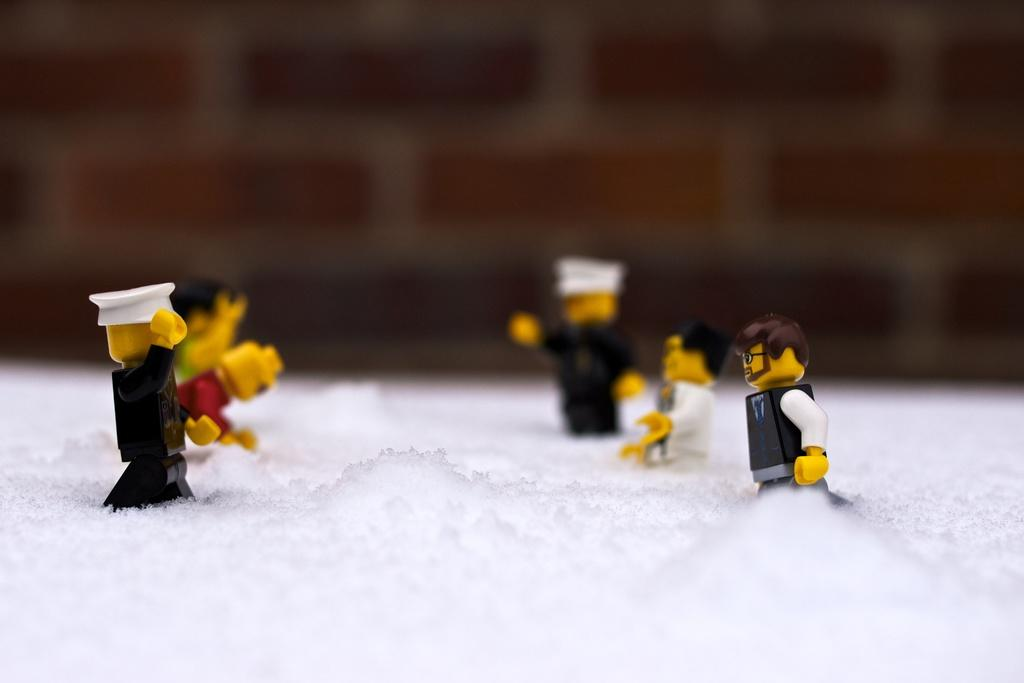What objects are present in the image? There are toys in the image. Where are the toys located in the image? The toys are on both the right and left sides of the image. What is the setting of the image? The toys are in the snow. What is the desire of the toys in the image? There is no indication of the toys having desires in the image. --- 